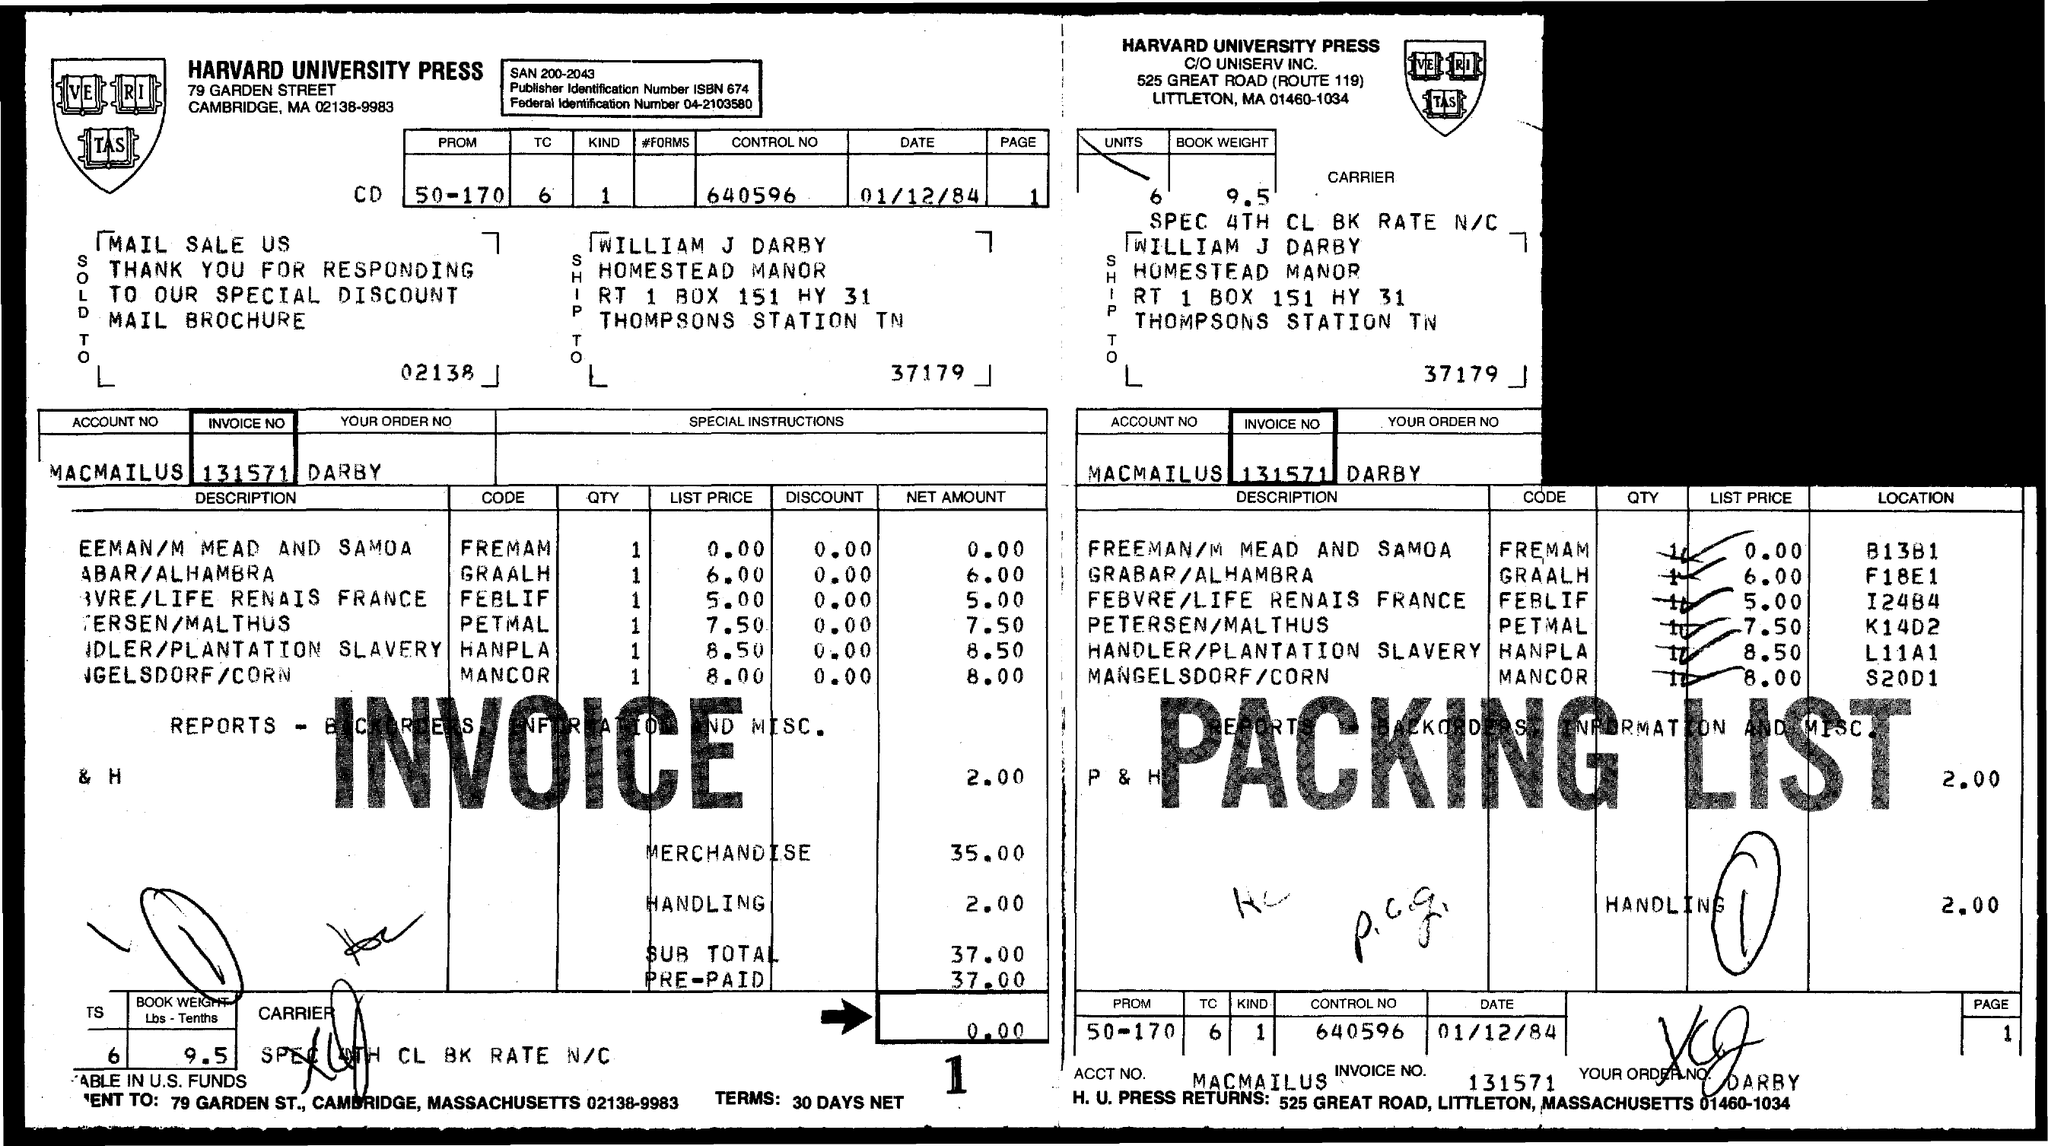Highlight a few significant elements in this photo. What is the invoice number 131571...?" is a question asking for information about an invoice number. The subtotal of the invoice is 37.00. 